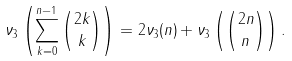<formula> <loc_0><loc_0><loc_500><loc_500>\nu _ { 3 } \left ( \sum _ { k = 0 } ^ { n - 1 } \binom { 2 k } { k } \right ) = 2 \nu _ { 3 } ( n ) + \nu _ { 3 } \left ( \binom { 2 n } { n } \right ) .</formula> 